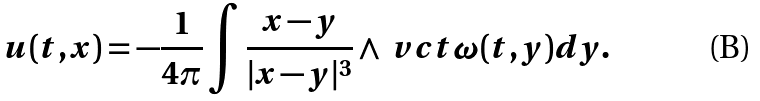<formula> <loc_0><loc_0><loc_500><loc_500>u ( t , x ) = - \frac { 1 } { 4 \pi } \int \frac { x - y } { | x - y | ^ { 3 } } \wedge \ v c t { \omega } ( t , y ) d y .</formula> 